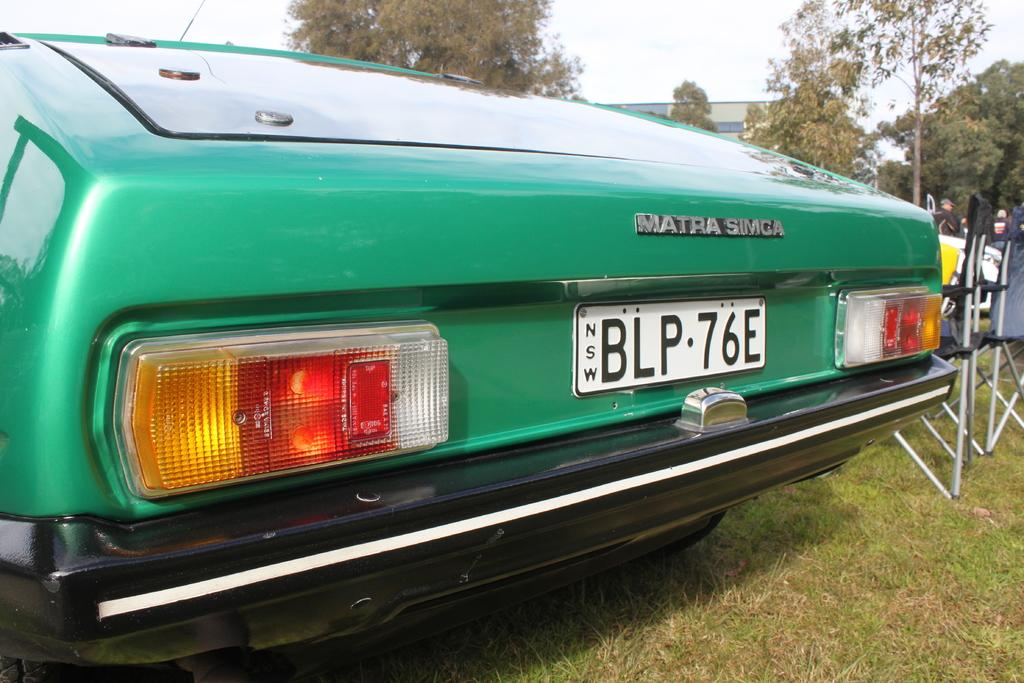What is located on the grass in the image? There is a car on the grass in the image. What objects are beside the car? There are chairs beside the car. What can be seen in the background of the image? There is a building and trees in the background of the image. What type of carriage can be seen transporting passengers at the airport in the image? There is no carriage or airport present in the image; it features a car on the grass with chairs beside it and a background with a building and trees. 